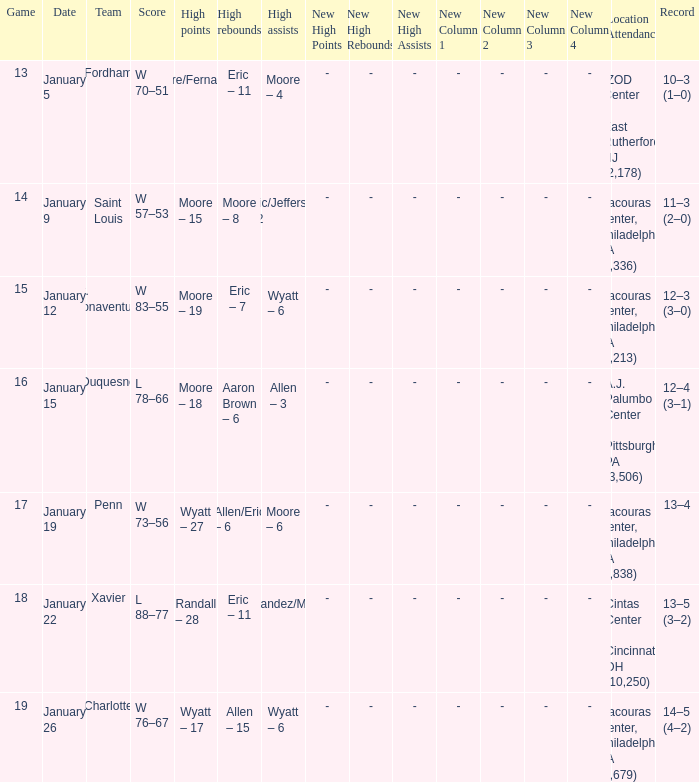Who had the most assists and how many did they have on January 5? Moore – 4. 